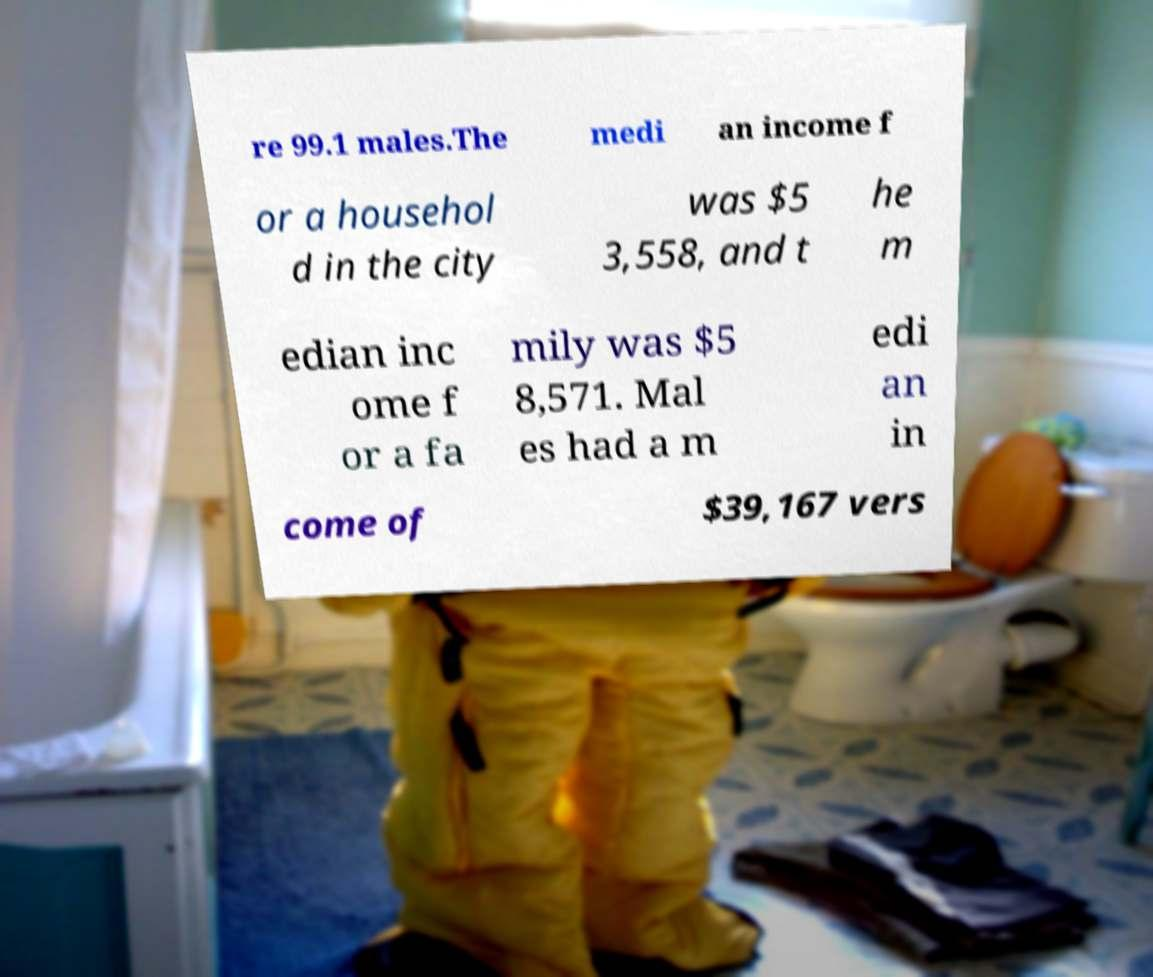I need the written content from this picture converted into text. Can you do that? re 99.1 males.The medi an income f or a househol d in the city was $5 3,558, and t he m edian inc ome f or a fa mily was $5 8,571. Mal es had a m edi an in come of $39,167 vers 